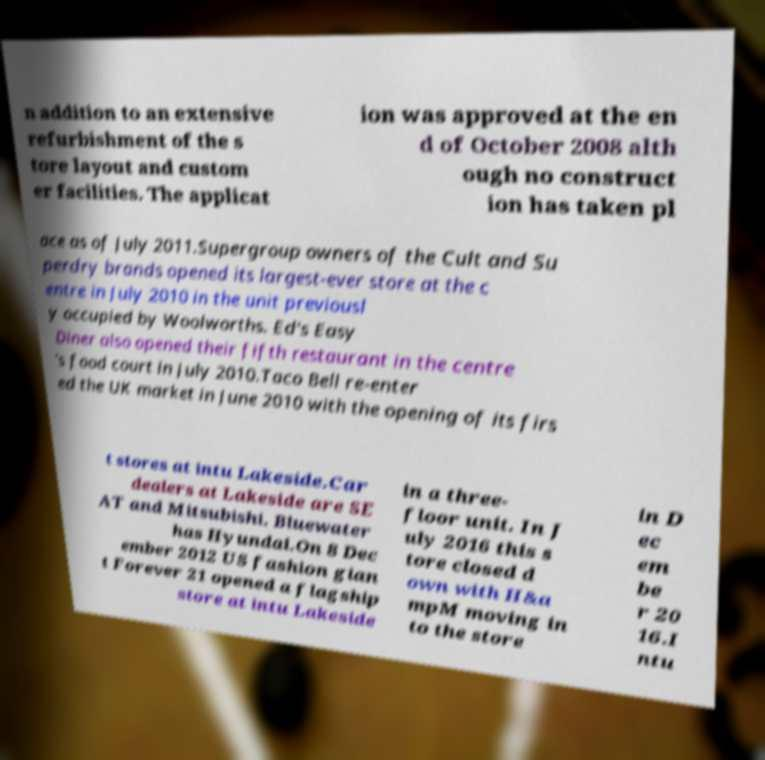Could you extract and type out the text from this image? n addition to an extensive refurbishment of the s tore layout and custom er facilities. The applicat ion was approved at the en d of October 2008 alth ough no construct ion has taken pl ace as of July 2011.Supergroup owners of the Cult and Su perdry brands opened its largest-ever store at the c entre in July 2010 in the unit previousl y occupied by Woolworths. Ed's Easy Diner also opened their fifth restaurant in the centre 's food court in July 2010.Taco Bell re-enter ed the UK market in June 2010 with the opening of its firs t stores at intu Lakeside.Car dealers at Lakeside are SE AT and Mitsubishi. Bluewater has Hyundai.On 8 Dec ember 2012 US fashion gian t Forever 21 opened a flagship store at intu Lakeside in a three- floor unit. In J uly 2016 this s tore closed d own with H&a mpM moving in to the store in D ec em be r 20 16.I ntu 